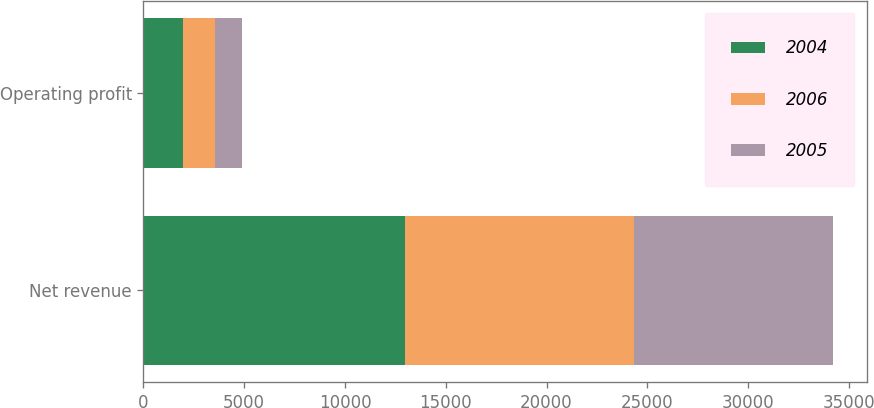Convert chart. <chart><loc_0><loc_0><loc_500><loc_500><stacked_bar_chart><ecel><fcel>Net revenue<fcel>Operating profit<nl><fcel>2004<fcel>12959<fcel>1948<nl><fcel>2006<fcel>11376<fcel>1607<nl><fcel>2005<fcel>9862<fcel>1323<nl></chart> 